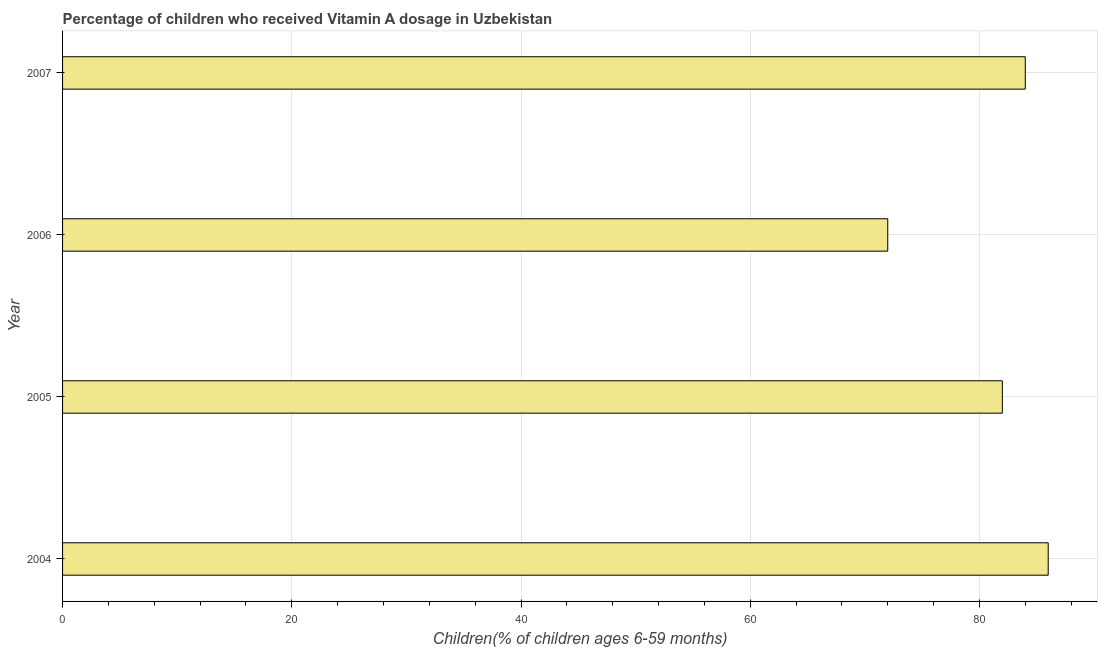Does the graph contain any zero values?
Ensure brevity in your answer.  No. Does the graph contain grids?
Your answer should be compact. Yes. What is the title of the graph?
Offer a very short reply. Percentage of children who received Vitamin A dosage in Uzbekistan. What is the label or title of the X-axis?
Your answer should be very brief. Children(% of children ages 6-59 months). What is the label or title of the Y-axis?
Keep it short and to the point. Year. What is the vitamin a supplementation coverage rate in 2007?
Your response must be concise. 84. Across all years, what is the maximum vitamin a supplementation coverage rate?
Ensure brevity in your answer.  86. In which year was the vitamin a supplementation coverage rate maximum?
Your answer should be very brief. 2004. In which year was the vitamin a supplementation coverage rate minimum?
Provide a short and direct response. 2006. What is the sum of the vitamin a supplementation coverage rate?
Your answer should be compact. 324. What is the difference between the vitamin a supplementation coverage rate in 2006 and 2007?
Offer a very short reply. -12. In how many years, is the vitamin a supplementation coverage rate greater than 76 %?
Keep it short and to the point. 3. What is the ratio of the vitamin a supplementation coverage rate in 2004 to that in 2005?
Ensure brevity in your answer.  1.05. What is the difference between the highest and the lowest vitamin a supplementation coverage rate?
Offer a very short reply. 14. What is the Children(% of children ages 6-59 months) of 2005?
Keep it short and to the point. 82. What is the Children(% of children ages 6-59 months) of 2006?
Make the answer very short. 72. What is the Children(% of children ages 6-59 months) of 2007?
Make the answer very short. 84. What is the difference between the Children(% of children ages 6-59 months) in 2004 and 2005?
Offer a terse response. 4. What is the difference between the Children(% of children ages 6-59 months) in 2004 and 2007?
Provide a succinct answer. 2. What is the difference between the Children(% of children ages 6-59 months) in 2005 and 2006?
Keep it short and to the point. 10. What is the ratio of the Children(% of children ages 6-59 months) in 2004 to that in 2005?
Ensure brevity in your answer.  1.05. What is the ratio of the Children(% of children ages 6-59 months) in 2004 to that in 2006?
Give a very brief answer. 1.19. What is the ratio of the Children(% of children ages 6-59 months) in 2004 to that in 2007?
Make the answer very short. 1.02. What is the ratio of the Children(% of children ages 6-59 months) in 2005 to that in 2006?
Provide a succinct answer. 1.14. What is the ratio of the Children(% of children ages 6-59 months) in 2006 to that in 2007?
Keep it short and to the point. 0.86. 